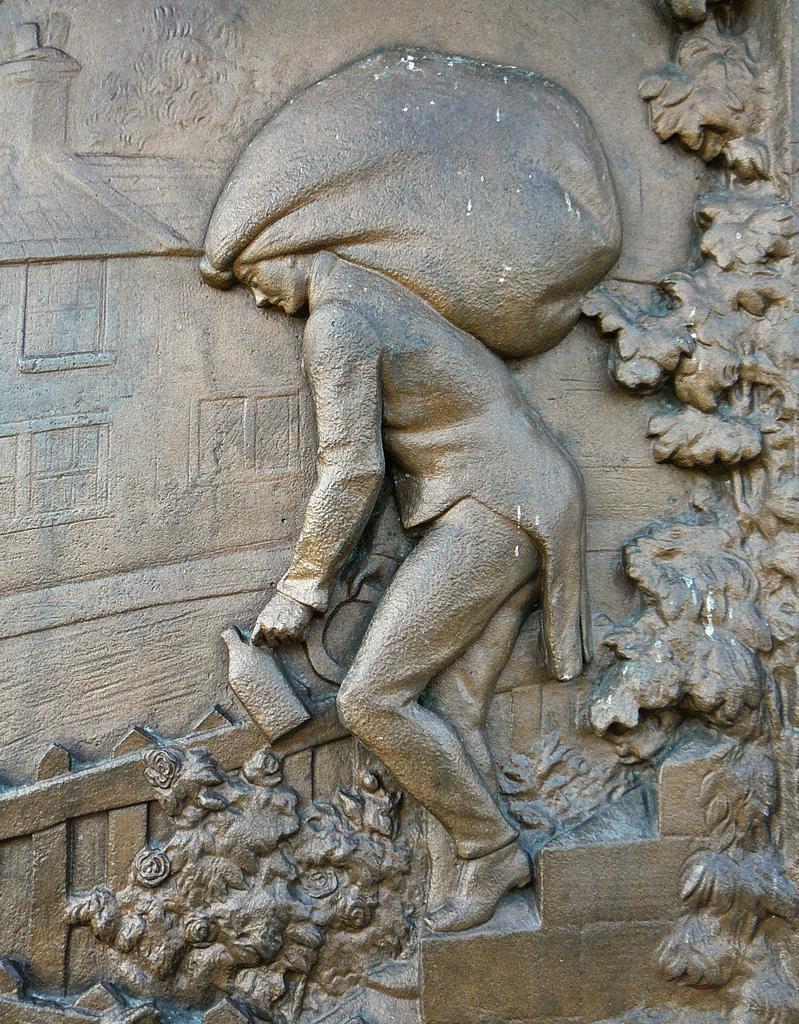Can you describe this image briefly? In the picture I can see a sculpture of a person holding an object and there are some other objects on the wall beside it. 